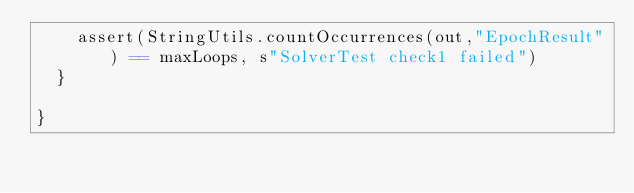Convert code to text. <code><loc_0><loc_0><loc_500><loc_500><_Scala_>    assert(StringUtils.countOccurrences(out,"EpochResult") == maxLoops, s"SolverTest check1 failed")
  }

}
</code> 